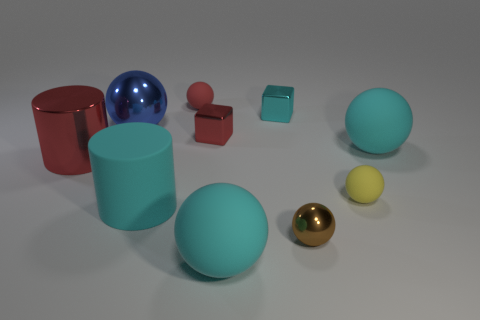What number of brown things are in front of the big cyan cylinder?
Your answer should be compact. 1. What material is the large blue sphere?
Provide a short and direct response. Metal. What is the color of the cylinder in front of the red object that is in front of the big cyan thing behind the cyan cylinder?
Offer a very short reply. Cyan. How many brown metallic things are the same size as the brown metallic ball?
Your answer should be compact. 0. The big metal thing on the right side of the big metal cylinder is what color?
Make the answer very short. Blue. How many other objects are there of the same size as the red cylinder?
Ensure brevity in your answer.  4. How big is the rubber sphere that is in front of the big blue object and on the left side of the tiny brown thing?
Provide a short and direct response. Large. There is a large rubber cylinder; is its color the same as the big sphere right of the yellow rubber sphere?
Your answer should be compact. Yes. Is there a small red thing of the same shape as the cyan metallic thing?
Make the answer very short. Yes. How many objects are either red objects or objects in front of the yellow thing?
Ensure brevity in your answer.  6. 